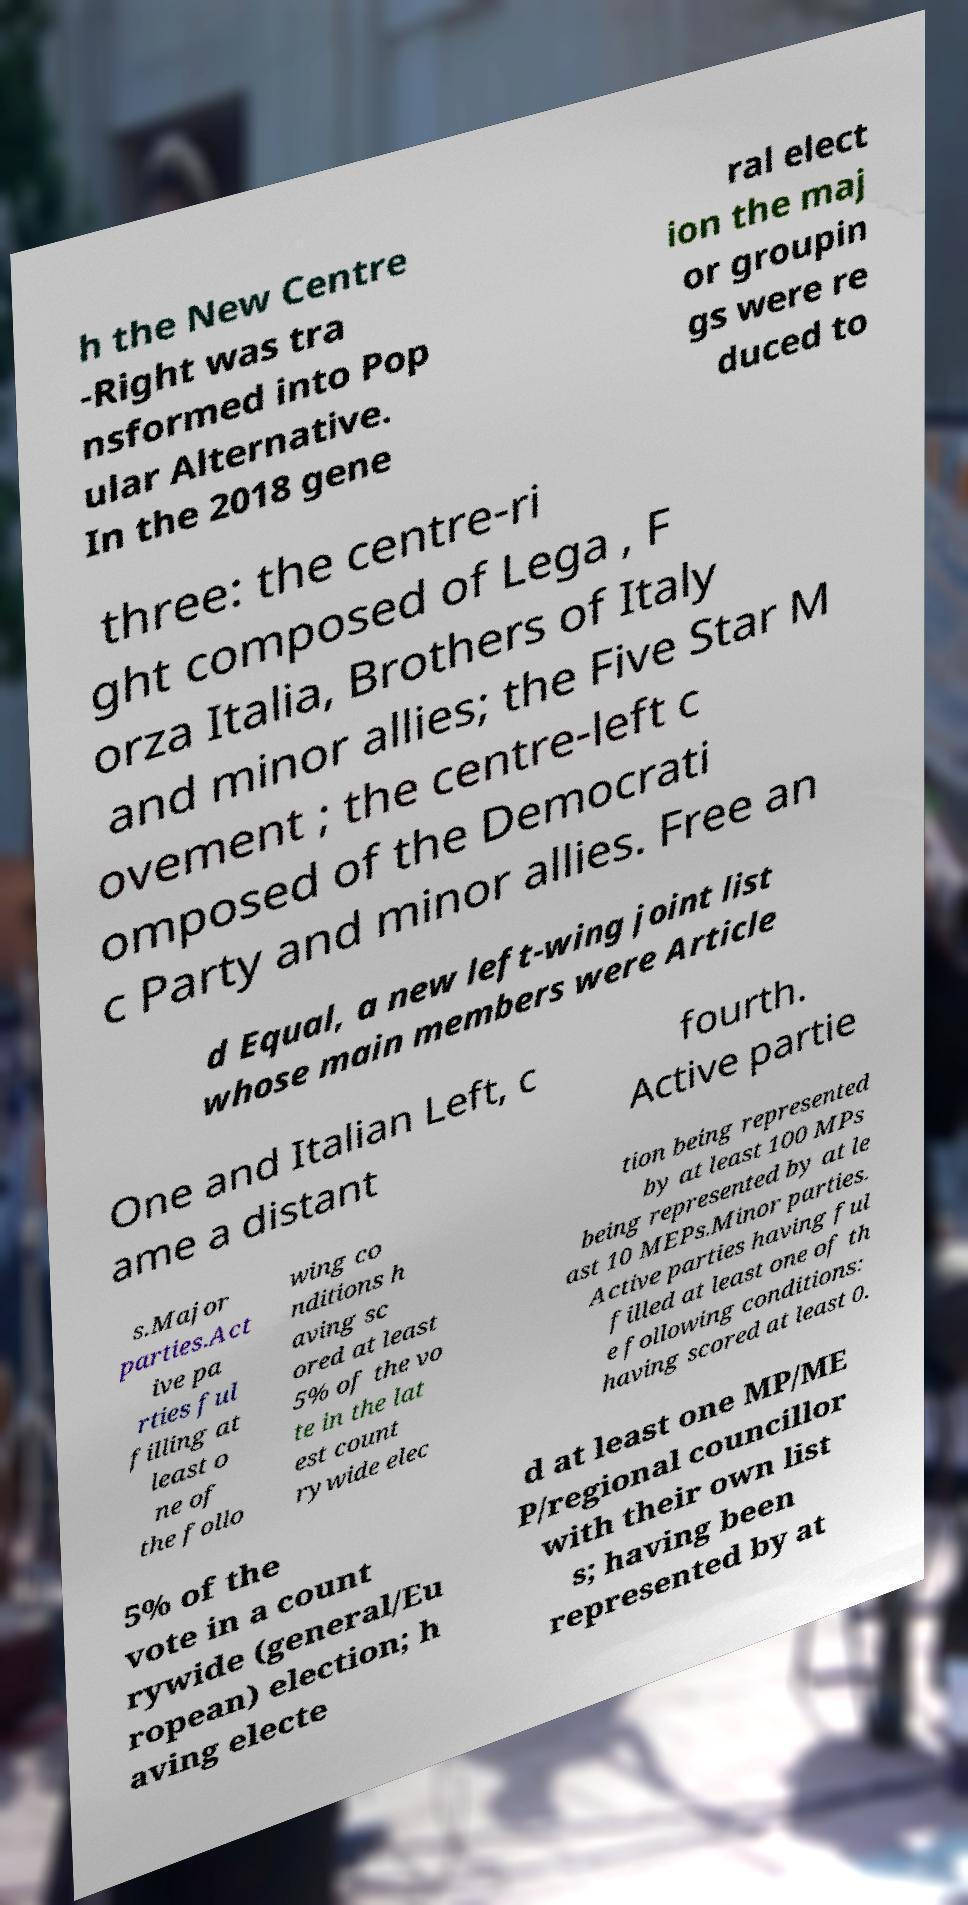What messages or text are displayed in this image? I need them in a readable, typed format. h the New Centre -Right was tra nsformed into Pop ular Alternative. In the 2018 gene ral elect ion the maj or groupin gs were re duced to three: the centre-ri ght composed of Lega , F orza Italia, Brothers of Italy and minor allies; the Five Star M ovement ; the centre-left c omposed of the Democrati c Party and minor allies. Free an d Equal, a new left-wing joint list whose main members were Article One and Italian Left, c ame a distant fourth. Active partie s.Major parties.Act ive pa rties ful filling at least o ne of the follo wing co nditions h aving sc ored at least 5% of the vo te in the lat est count rywide elec tion being represented by at least 100 MPs being represented by at le ast 10 MEPs.Minor parties. Active parties having ful filled at least one of th e following conditions: having scored at least 0. 5% of the vote in a count rywide (general/Eu ropean) election; h aving electe d at least one MP/ME P/regional councillor with their own list s; having been represented by at 